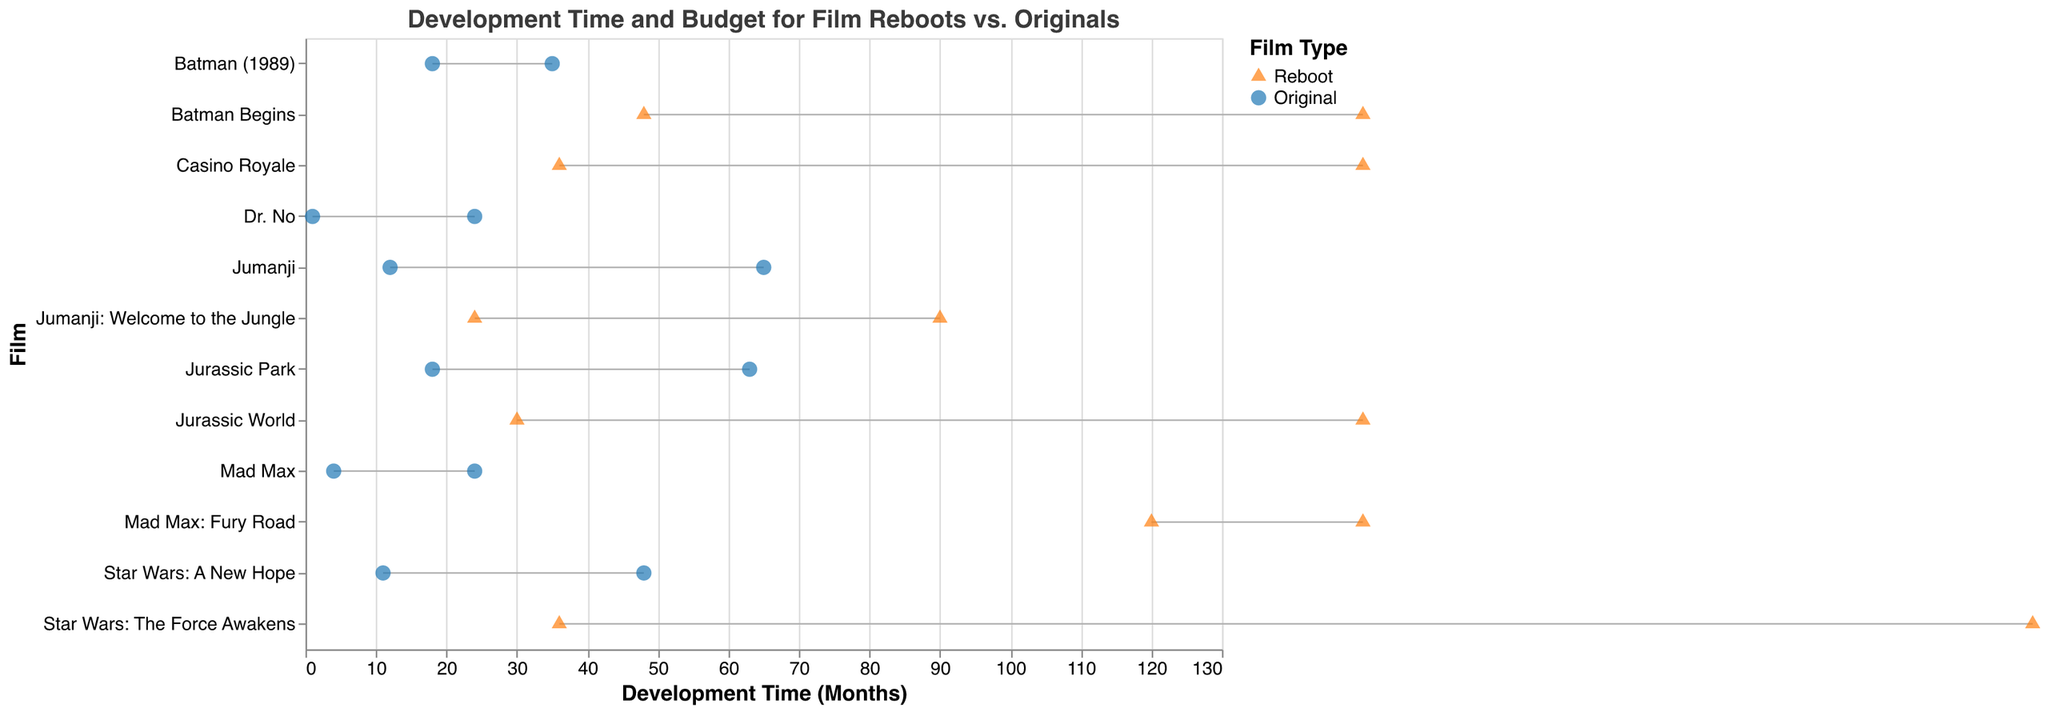What's the title of the plot? The title is typically placed at the top of the figure and gives an overview of the data being presented. In this plot, the title is: "Development Time and Budget for Film Reboots vs. Originals".
Answer: Development Time and Budget for Film Reboots vs. Originals What are the categories represented by different shapes in the plot? The shapes represent different categories. Triangles represent "Reboot" and circles represent "Original". This can be determined by looking at the legend.
Answer: Reboot and Original Which film had the longest development time among the reboots? To find this, look for the film with the highest value on the development time axis among the trianglular points. "Mad Max: Fury Road" has the longest development time at 120 months.
Answer: Mad Max: Fury Road Compare the budget of "Star Wars: A New Hope" and "Star Wars: The Force Awakens". Which one has a higher budget? The budgets can be compared by looking at the x-axis values of both films. "Star Wars: The Force Awakens" has a budget of 245 million, whereas "Star Wars: A New Hope" has a budget of 11 million.
Answer: Star Wars: The Force Awakens What is the development time difference between "Jurassic Park" and its reboot "Jurassic World"? Subtract the development time of "Jurassic Park" from "Jurassic World". Jurassic World (Reboot) has 30 months, and Jurassic Park (Original) has 18 months. The difference is calculated as 30 - 18.
Answer: 12 months Which original film had the lowest budget? Look for the smallest value on the budget axis among the circular points (representing original films). "Dr. No" had the lowest budget at 1 million.
Answer: Dr. No Calculate the average budget for all the reboots. Add the budgets of all reboots and divide by the number of reboots. The reboots and their budgets are: Jurassic World (150M), Mad Max: Fury Road (150M), Star Wars: The Force Awakens (245M), Batman Begins (150M), Casino Royale (150M), Jumanji: Welcome to the Jungle (90M). Total = 150+150+245+150+150+90 = 935. Average = 935 / 6.
Answer: 155.83 million Is there any film with the same development time for both its original and reboot versions? Look for pairs of films where the points align vertically on the development time axis. "Jumanji" and "Jumanji: Welcome to the Jungle" both have a development time of 24 months.
Answer: Yes, Jumanji Which film has the highest overall budget (combining originals and reboots)? Look for the largest value on the budget axis regardless of category. "Star Wars: The Force Awakens" has the highest budget.
Answer: Star Wars: The Force Awakens What trend can you observe in the development time of original films compared to their reboots? Compare the development times between original films and their respective reboots. Generally, reboots have longer development times compared to a few original counterparts, like "Mad Max: Fury Road" and "Batman Begins".
Answer: Reboots generally have longer development times 